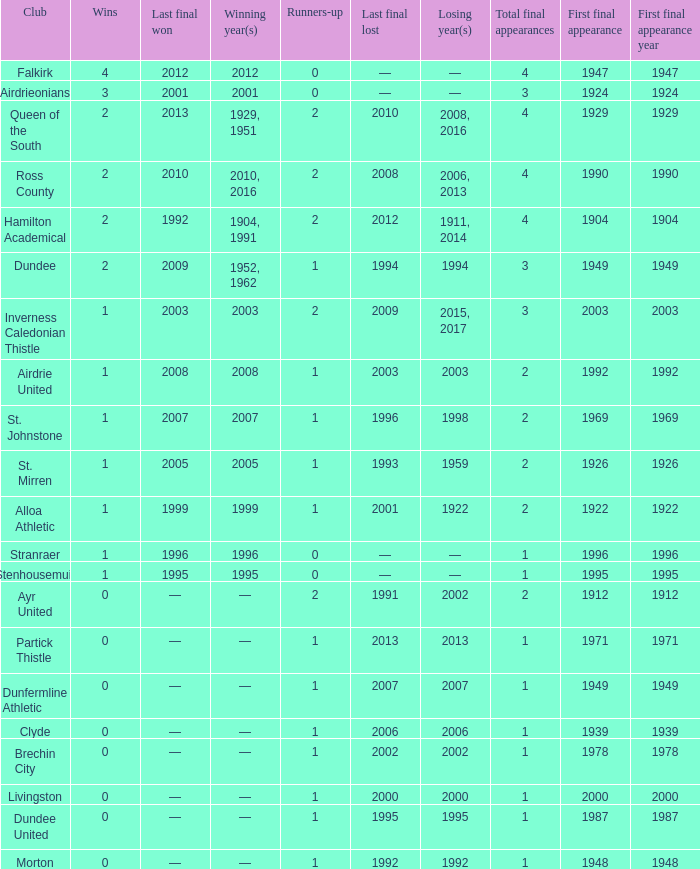What club has over 1 runners-up and last won the final in 2010? Ross County. 